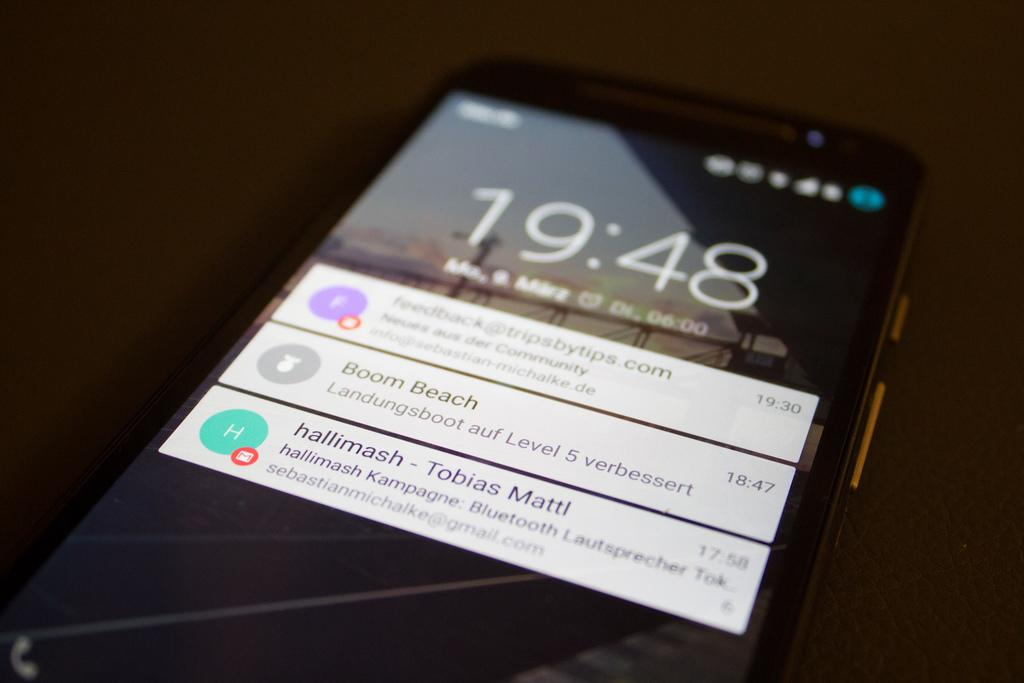<image>
Write a terse but informative summary of the picture. An iPhone sits on a table at 19:48 with unread emails from Boom Beach and hallimash. 